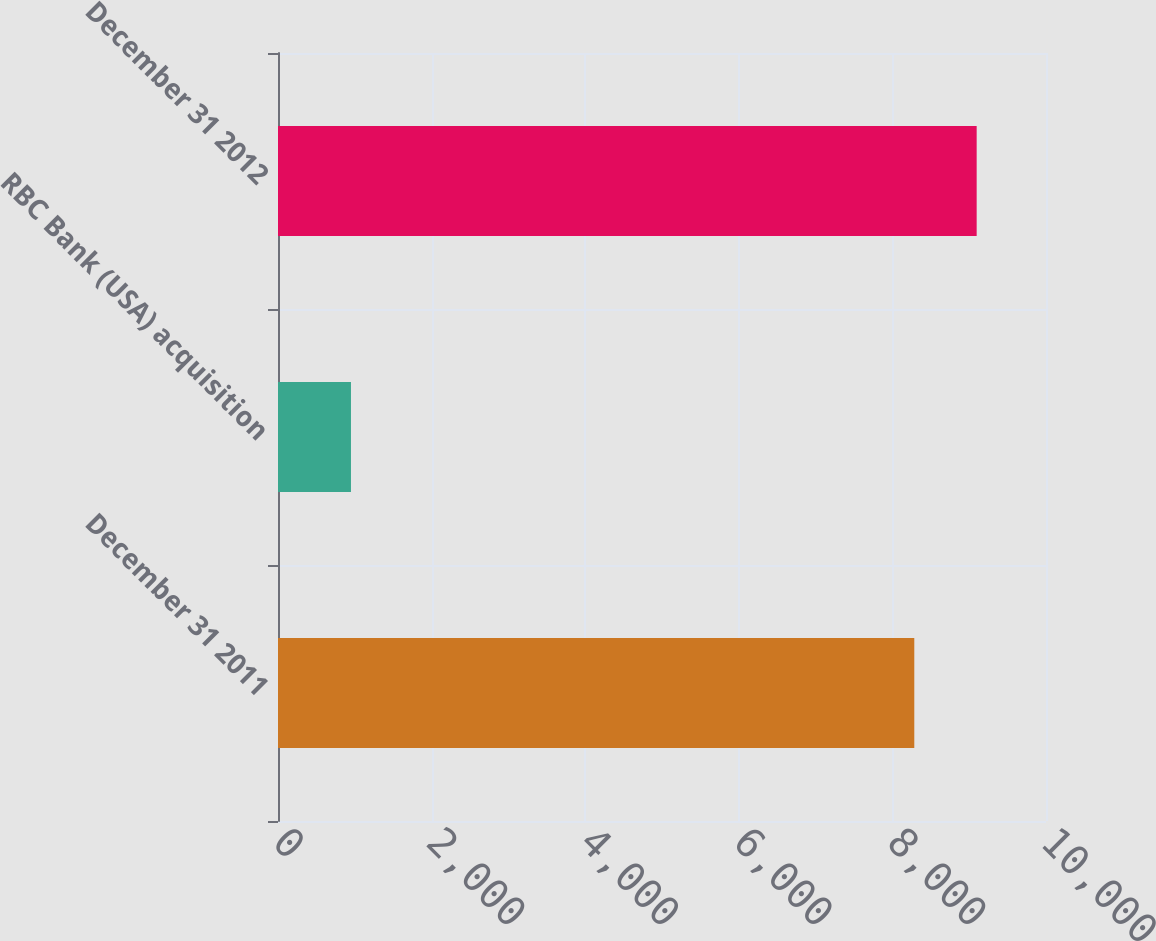<chart> <loc_0><loc_0><loc_500><loc_500><bar_chart><fcel>December 31 2011<fcel>RBC Bank (USA) acquisition<fcel>December 31 2012<nl><fcel>8285<fcel>950<fcel>9097.2<nl></chart> 